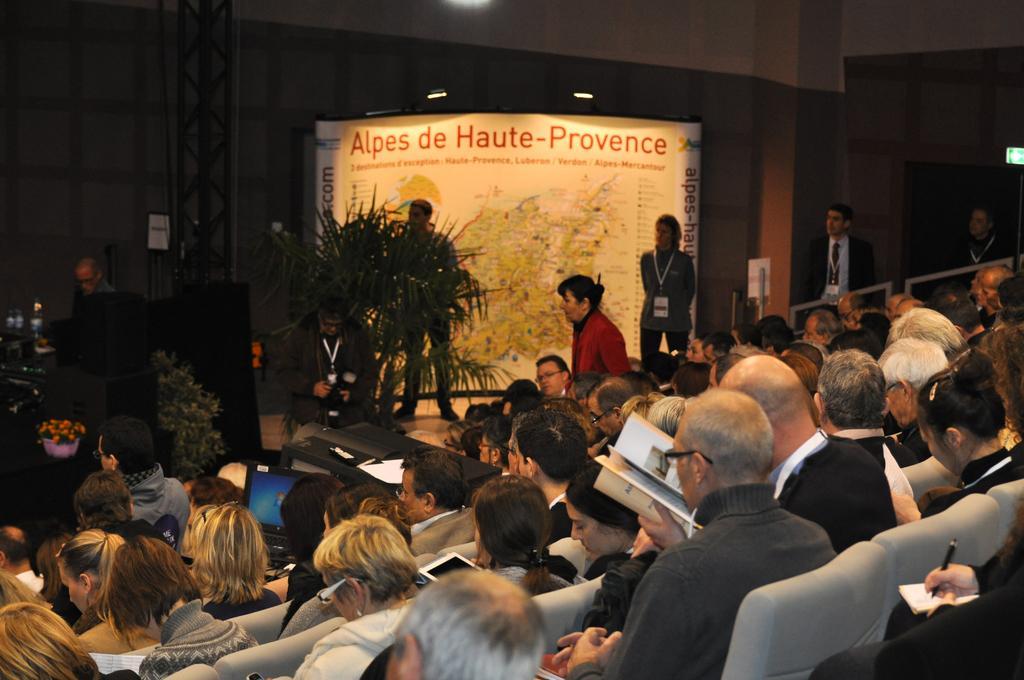How would you summarize this image in a sentence or two? In this picture we can see a group of people sitting on chairs, laptop, tab, books, pen, plants, banner, some people are standing on the floor and some objects. In the background we can see the lights and walls. 